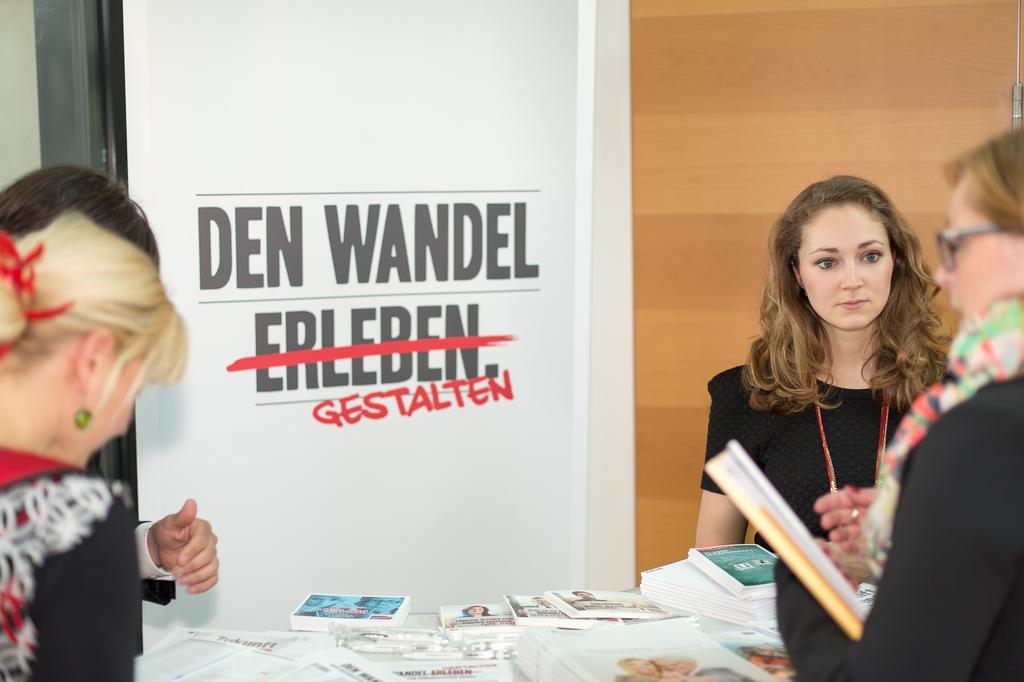In one or two sentences, can you explain what this image depicts? In this image, there is a printed text on the wall and there are four people and there is a person at the right corner who is reading a book and there is a table where there are number of books which are placed on the table. 